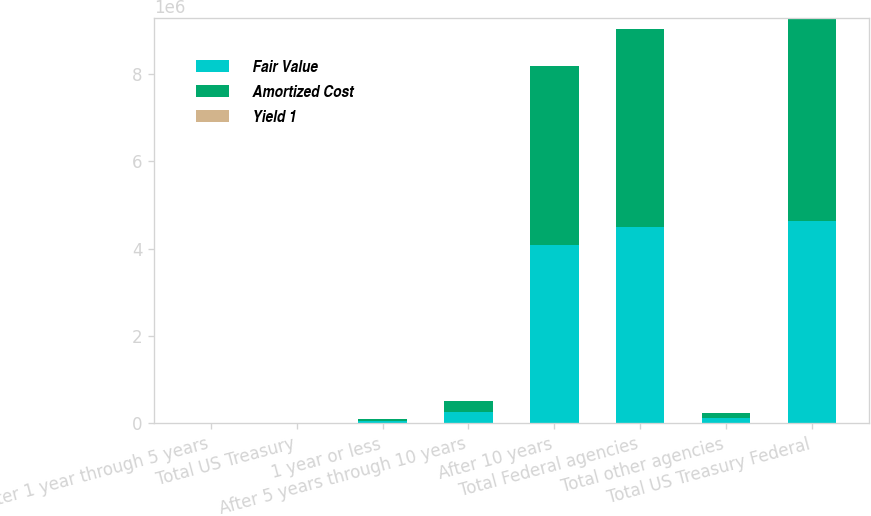<chart> <loc_0><loc_0><loc_500><loc_500><stacked_bar_chart><ecel><fcel>After 1 year through 5 years<fcel>Total US Treasury<fcel>1 year or less<fcel>After 5 years through 10 years<fcel>After 10 years<fcel>Total Federal agencies<fcel>Total other agencies<fcel>Total US Treasury Federal<nl><fcel>Fair Value<fcel>5457<fcel>5457<fcel>51146<fcel>254397<fcel>4.08812e+06<fcel>4.50532e+06<fcel>115076<fcel>4.62585e+06<nl><fcel>Amortized Cost<fcel>5472<fcel>5472<fcel>51050<fcel>257765<fcel>4.09948e+06<fcel>4.52169e+06<fcel>115913<fcel>4.64307e+06<nl><fcel>Yield 1<fcel>1.2<fcel>1.2<fcel>1.76<fcel>2.8<fcel>2.39<fcel>2.41<fcel>2.48<fcel>2.41<nl></chart> 